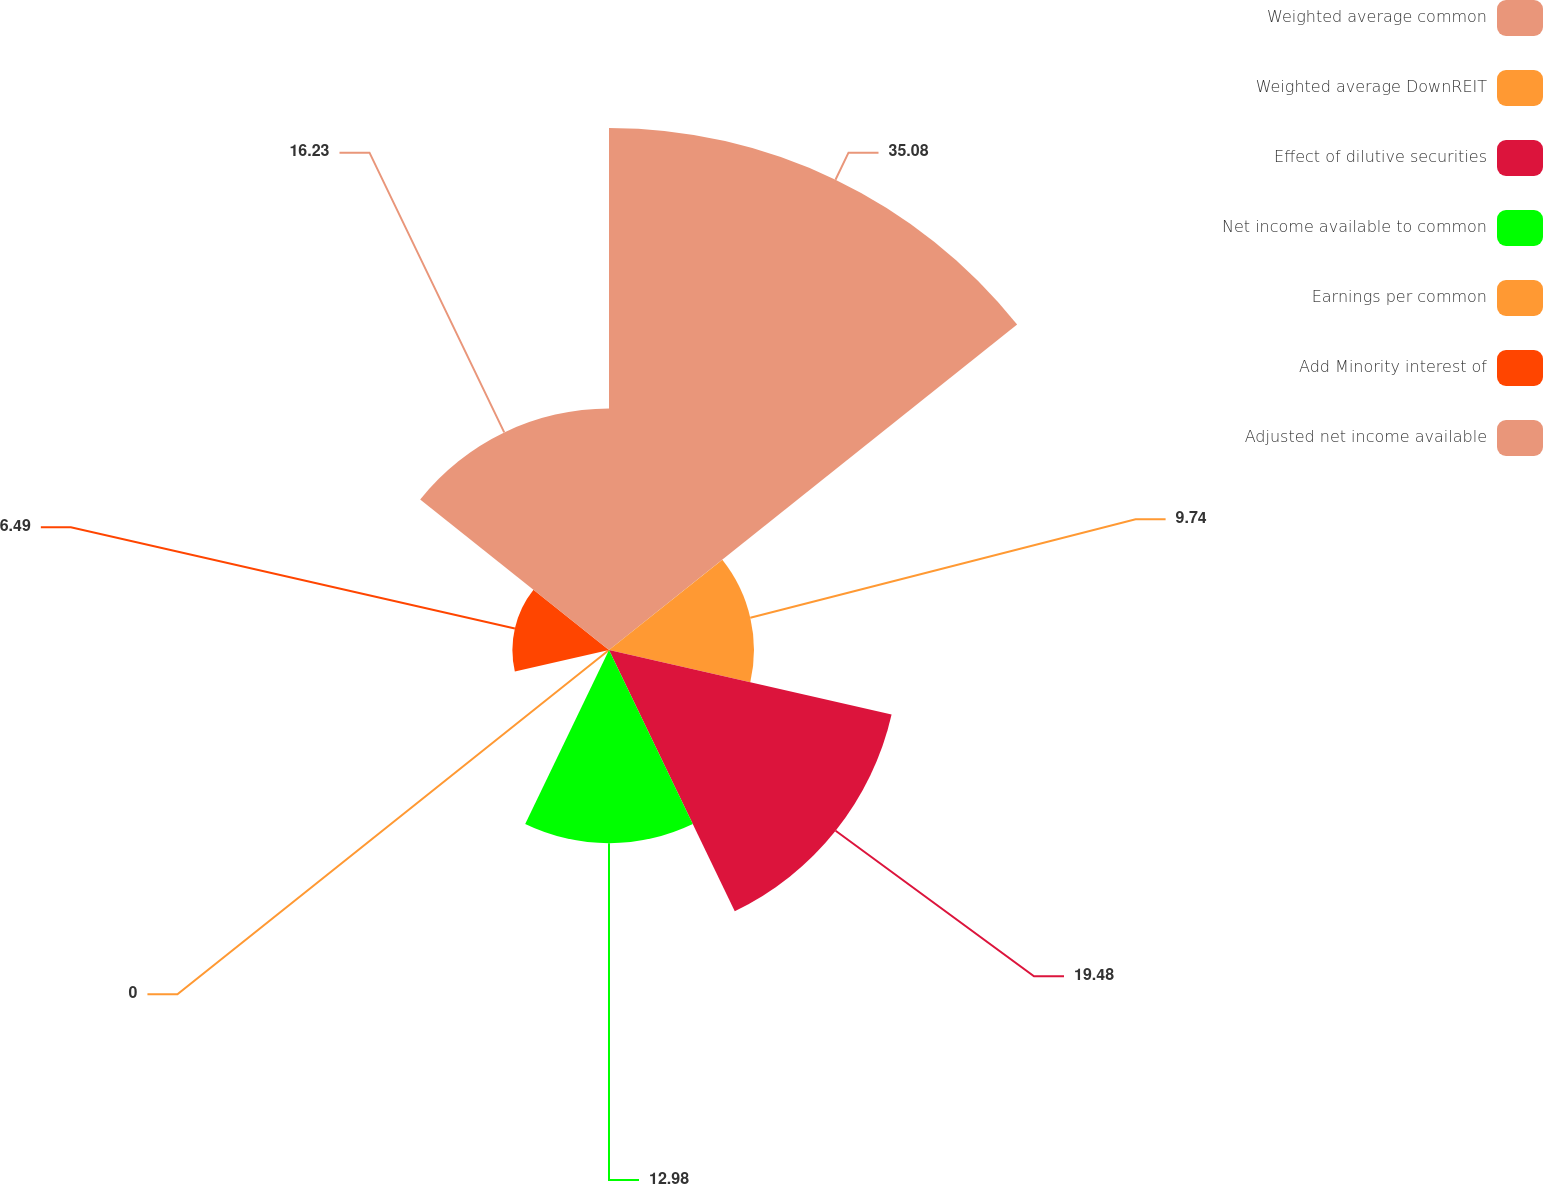Convert chart to OTSL. <chart><loc_0><loc_0><loc_500><loc_500><pie_chart><fcel>Weighted average common<fcel>Weighted average DownREIT<fcel>Effect of dilutive securities<fcel>Net income available to common<fcel>Earnings per common<fcel>Add Minority interest of<fcel>Adjusted net income available<nl><fcel>35.08%<fcel>9.74%<fcel>19.48%<fcel>12.98%<fcel>0.0%<fcel>6.49%<fcel>16.23%<nl></chart> 